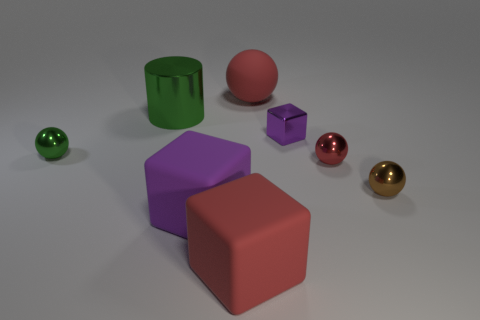Does the large matte thing behind the small purple metal object have the same color as the object that is in front of the purple rubber thing?
Offer a very short reply. Yes. What is the shape of the purple thing right of the rubber block that is to the right of the purple cube that is on the left side of the large red ball?
Provide a succinct answer. Cube. Is the shape of the tiny metallic thing in front of the small red object the same as the large red thing behind the small brown metal sphere?
Your answer should be very brief. Yes. What number of other things are the same material as the red block?
Your answer should be compact. 2. What shape is the purple object that is the same material as the brown sphere?
Your response must be concise. Cube. Is the size of the red shiny object the same as the red block?
Your answer should be compact. No. What is the size of the red matte thing to the left of the big red rubber object that is behind the tiny purple object?
Offer a very short reply. Large. There is a small shiny thing that is the same color as the big metal thing; what is its shape?
Your answer should be very brief. Sphere. How many cubes are either large blue metallic things or brown objects?
Offer a terse response. 0. Is the size of the purple matte thing the same as the red matte object to the left of the big red sphere?
Make the answer very short. Yes. 